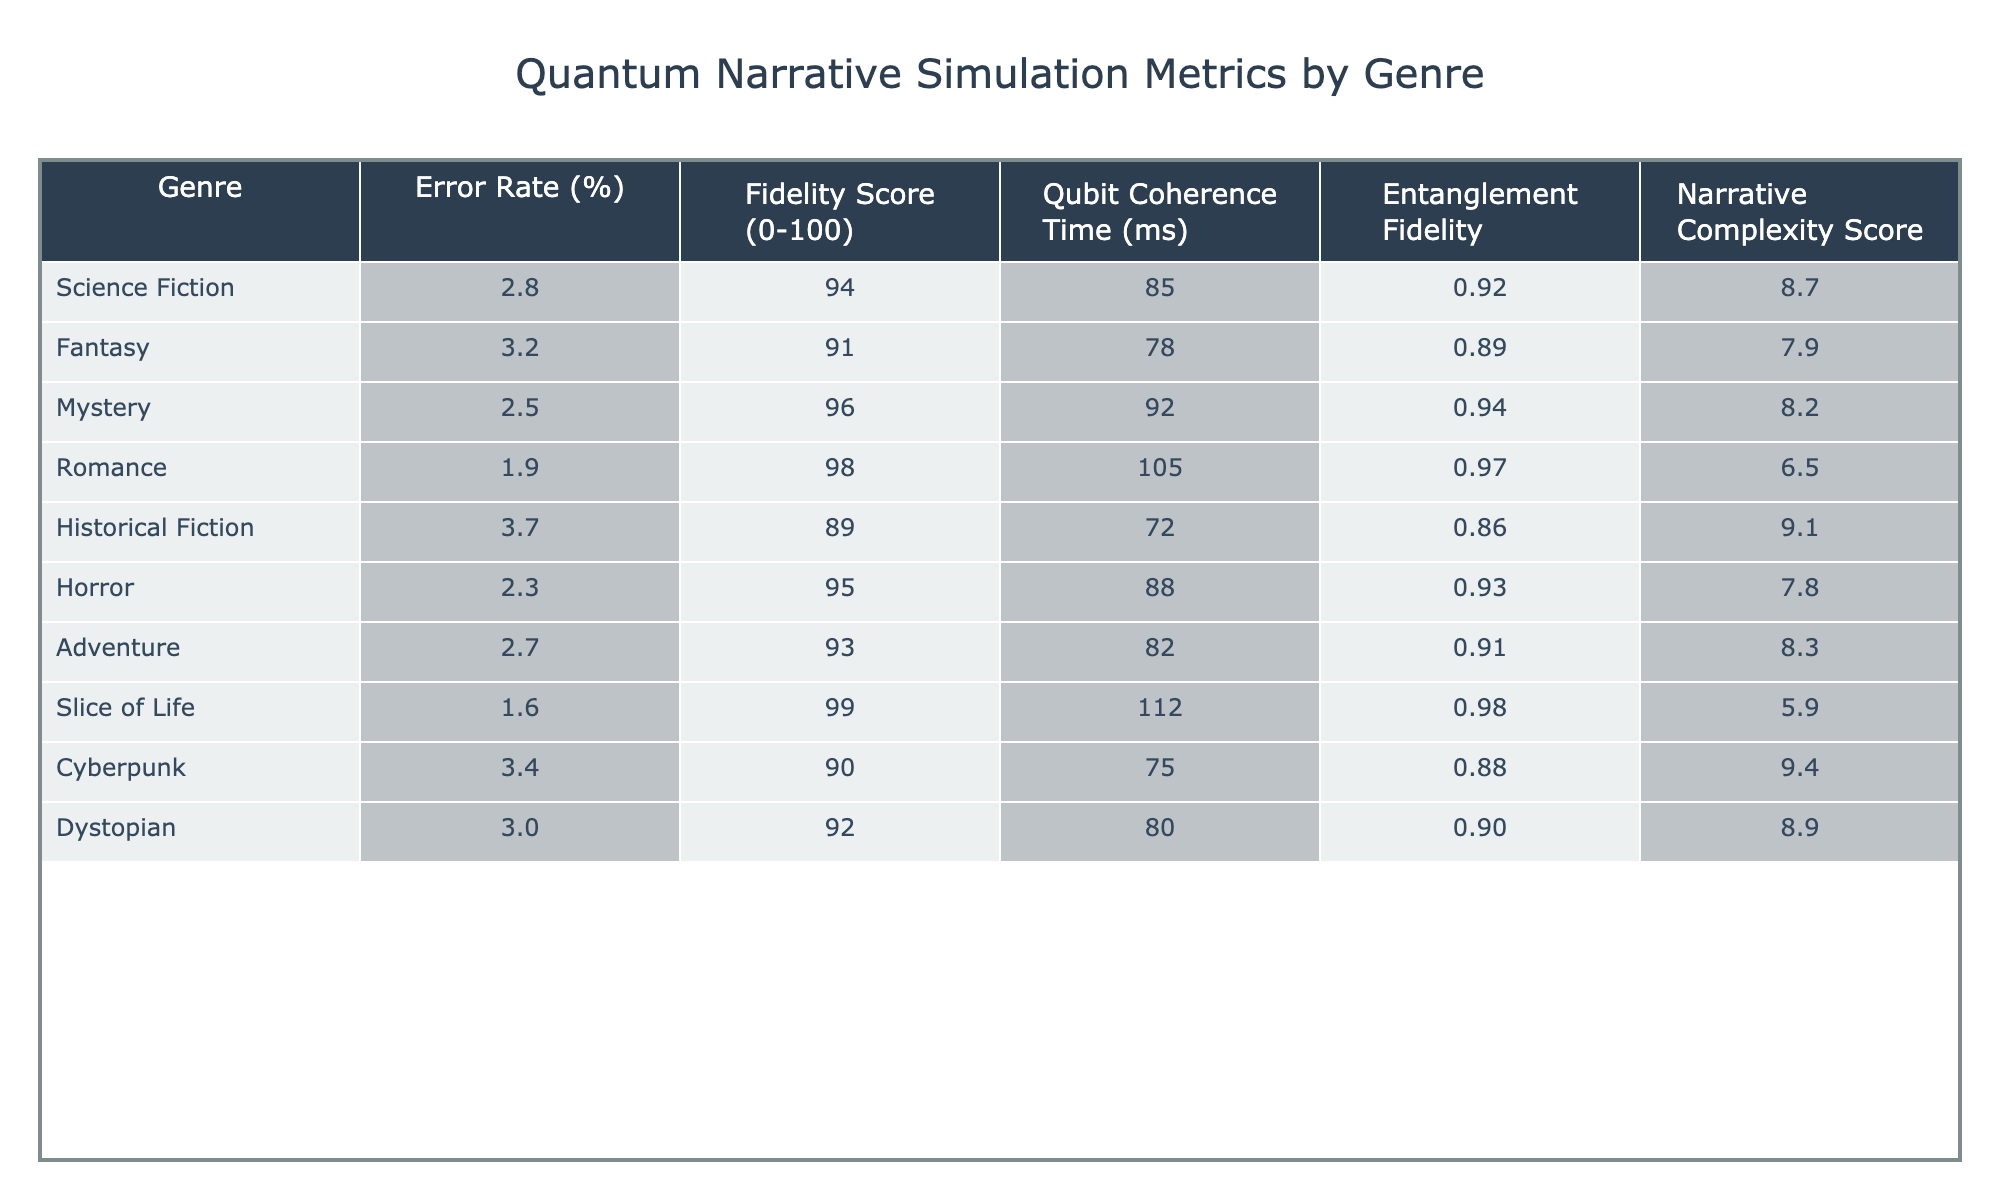What is the error rate for the Romance genre? According to the table, the error rate for the Romance genre is directly listed under the "Error Rate (%)" column. It shows a value of 1.9%.
Answer: 1.9% Which genre has the highest fidelity score? The "Fidelity Score (0-100)" column indicates that the Romance genre has the highest fidelity score of 98.
Answer: Romance What is the average error rate across all genres? To find the average error rate, sum all individual error rates (2.8 + 3.2 + 2.5 + 1.9 + 3.7 + 2.3 + 2.7 + 1.6 + 3.4 + 3.0) = 26.1. Then, divide by the total number of genres (10). So, 26.1 / 10 = 2.61%.
Answer: 2.61% Which genre has a qubit coherence time of 112 ms? By looking at the "Qubit Coherence Time (ms)" column, the genre with this coherence time is Slice of Life, as it is the only one listed with this specific value.
Answer: Slice of Life Is there a genre with both low error rate and high fidelity score? Yes, Slice of Life has the lowest error rate (1.6%) and the highest fidelity score (99), indicating it performs very well on both metrics.
Answer: Yes What is the difference in fidelity scores between Science Fiction and Horror? The fidelity score for Science Fiction is 94 and for Horror is 95. The difference is calculated as 95 - 94 = 1.
Answer: 1 Which genre has the lowest narrative complexity score, and what is that score? The "Narrative Complexity Score" column shows that Slice of Life has the lowest score at 5.9, making it the genre with the least complexity.
Answer: Slice of Life, 5.9 If a genre has an entanglement fidelity of 0.92, which genres could it possibly be? The genres listed with an entanglement fidelity of 0.92 are Science Fiction and Adventure, as both share this value.
Answer: Science Fiction, Adventure What is the sum of error rates for Fantasy and Cyberpunk? The error rate for Fantasy is 3.2% and for Cyberpunk is 3.4%. The sum is obtained by adding these two values: 3.2 + 3.4 = 6.6%.
Answer: 6.6% Is there a correlation between narrative complexity score and fidelity score? To analyze the correlation, we see that higher narrative complexity scores are associated with somewhat lower fidelity scores. For instance, Historical Fiction has the highest narrative complexity (9.1) and the lowest fidelity score (89). This suggests an inverse relationship.
Answer: Yes, there is a correlation indicating an inverse relationship 